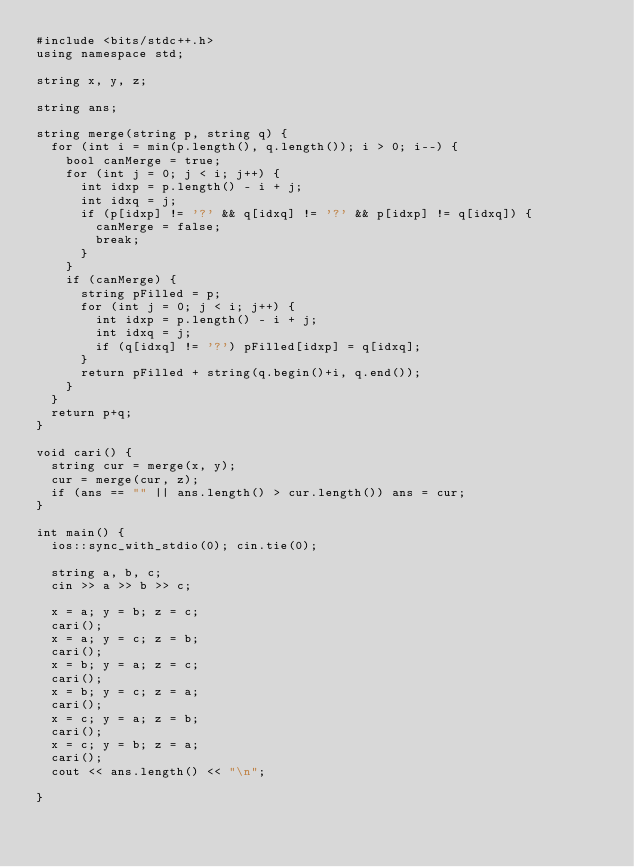<code> <loc_0><loc_0><loc_500><loc_500><_C++_>#include <bits/stdc++.h>
using namespace std;

string x, y, z;

string ans;

string merge(string p, string q) {
	for (int i = min(p.length(), q.length()); i > 0; i--) {
		bool canMerge = true;
		for (int j = 0; j < i; j++) {
			int idxp = p.length() - i + j;
			int idxq = j;
			if (p[idxp] != '?' && q[idxq] != '?' && p[idxp] != q[idxq]) {
				canMerge = false;
				break;
			}
		}
		if (canMerge) {
			string pFilled = p;
			for (int j = 0; j < i; j++) {
				int idxp = p.length() - i + j;
				int idxq = j;
				if (q[idxq] != '?') pFilled[idxp] = q[idxq];
			}
			return pFilled + string(q.begin()+i, q.end());
		}
	}
	return p+q;
}

void cari() {
	string cur = merge(x, y);
	cur = merge(cur, z);
	if (ans == "" || ans.length() > cur.length()) ans = cur;
}

int main() {
	ios::sync_with_stdio(0); cin.tie(0);

	string a, b, c;
	cin >> a >> b >> c;

	x = a; y = b; z = c;
	cari();
	x = a; y = c; z = b;
	cari();
	x = b; y = a; z = c;
	cari();
	x = b; y = c; z = a;
	cari();
	x = c; y = a; z = b;
	cari();
	x = c; y = b; z = a;
	cari();
	cout << ans.length() << "\n";

}</code> 